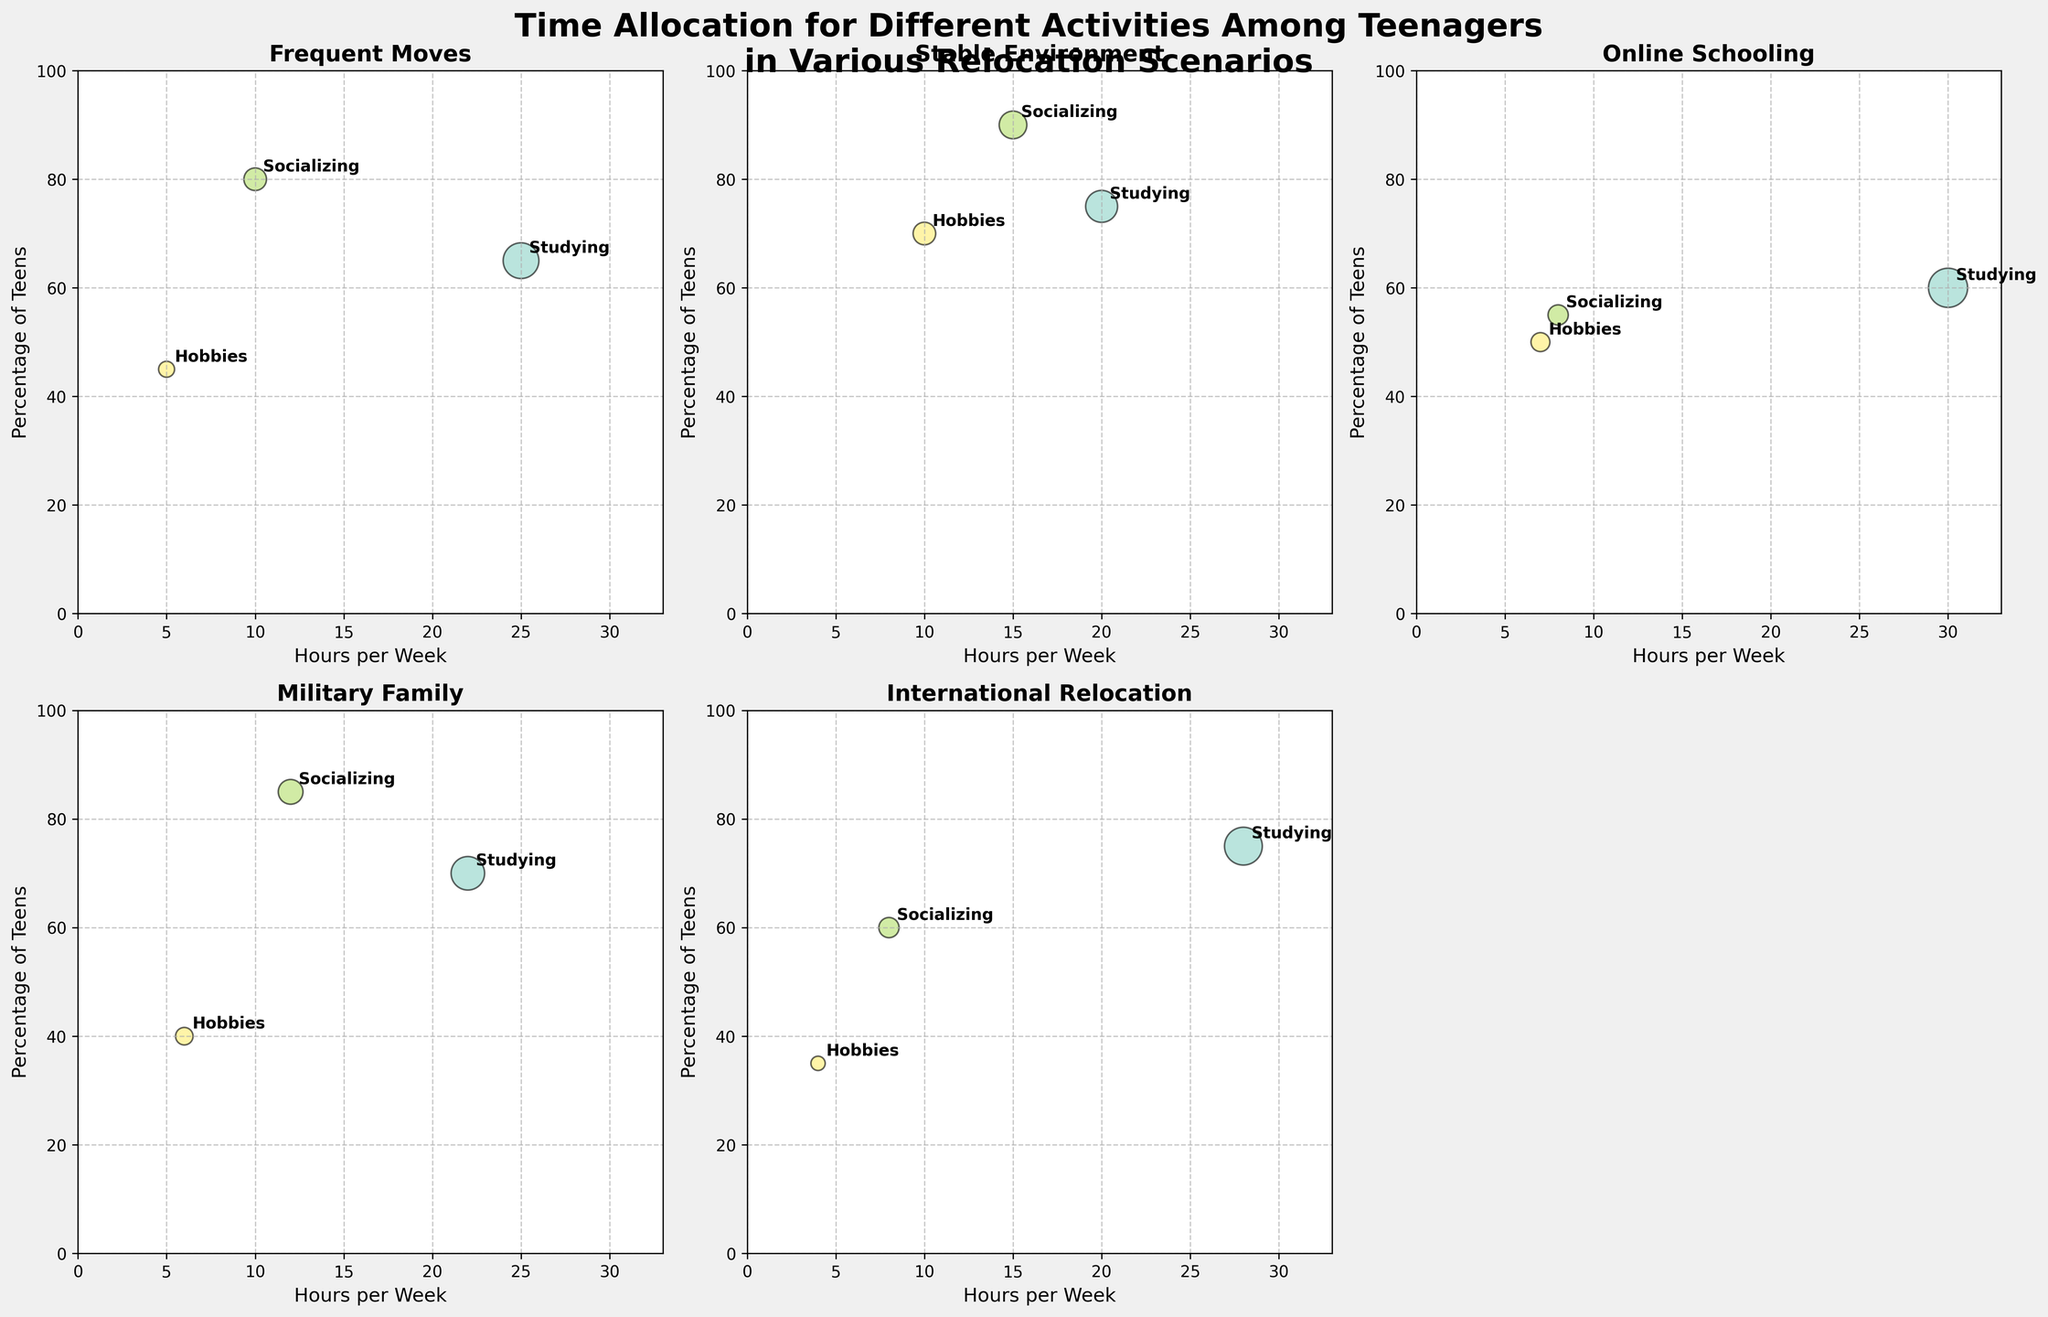What is the title of the plot? The title is located at the top of the figure, and it summarizes the content of the plot in a single sentence.
Answer: Time Allocation for Different Activities Among Teenagers in Various Relocation Scenarios How many different relocation scenarios are compared in the plot? By counting the number of titles in each subplot, we can determine the number of different relocation scenarios displayed. There are 5 scenarios: Frequent Moves, Stable Environment, Online Schooling, Military Family, and International Relocation.
Answer: 5 Which relocation scenario shows the highest percentage of teens socializing? By looking at the y-axis, which represents the percentage of teens, and locating the socializing data point across all subplots, we find that "Stable Environment" shows the highest value.
Answer: Stable Environment How does the number of hours spent on hobbies compare between military families and teenagers in a stable environment? From the subplots titled "Military Family" and "Stable Environment," compare the 'Hours per Week' values for hobbies. Military families spend 6 hours, and teens in stable environments spend 10 hours on hobbies.
Answer: Teens in stable environments spend 4 more hours on hobbies What is the average percentage of teens studying in scenarios with frequent moves and international relocation? Find the percentages for studying in both "Frequent Moves" and "International Relocation" scenarios (65% and 75%, respectively), add them together and divide by 2. (65 + 75) / 2 = 70
Answer: 70 Which activity has the largest bubble in the "Online Schooling" scenario? The size of the bubbles represents the 'Hours per Week' spent on each activity. In the "Online Schooling" subplot, the largest bubble corresponds to studying with 30 hours per week.
Answer: Studying What is the difference in the number of hours per week spent studying between teens in military families and those experiencing frequent moves? Find the 'Hours per Week' values for studying in the subplots of "Military Family" and "Frequent Moves" (22 hours and 25 hours, respectively) and calculate the difference. 25 - 22 = 3
Answer: 3 hours Which scenario has the lowest percentage of teens engaged in hobbies? Look across all scenarios at the y-axis values corresponding to hobbies. The "International Relocation" scenario has the lowest percentage at 35%.
Answer: International Relocation In which scenario did teens allocate the least amount of time to socializing? By examining the x-axis values for socializing across all scenarios, the "Online Schooling" scenario has the least hours spent on socializing with 8 hours per week.
Answer: Online Schooling 